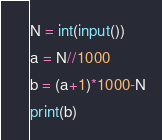Convert code to text. <code><loc_0><loc_0><loc_500><loc_500><_Python_>N = int(input())
a = N//1000
b = (a+1)*1000-N
print(b)</code> 